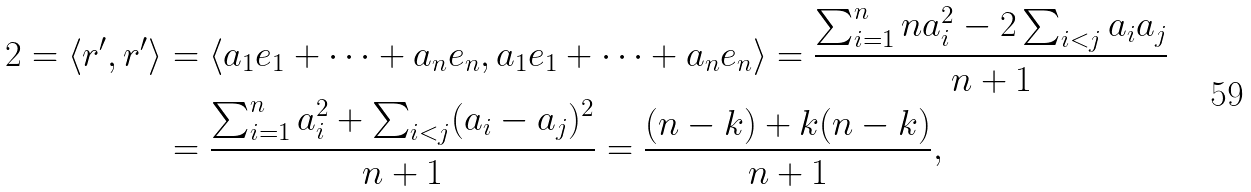<formula> <loc_0><loc_0><loc_500><loc_500>2 = \left \langle r ^ { \prime } , r ^ { \prime } \right \rangle & = \left \langle a _ { 1 } e _ { 1 } + \cdots + a _ { n } e _ { n } , a _ { 1 } e _ { 1 } + \cdots + a _ { n } e _ { n } \right \rangle = \frac { \sum _ { i = 1 } ^ { n } n a _ { i } ^ { 2 } - 2 \sum _ { i < j } a _ { i } a _ { j } } { n + 1 } \\ & = \frac { \sum _ { i = 1 } ^ { n } a _ { i } ^ { 2 } + \sum _ { i < j } ( a _ { i } - a _ { j } ) ^ { 2 } } { n + 1 } = \frac { ( n - k ) + k ( n - k ) } { n + 1 } ,</formula> 